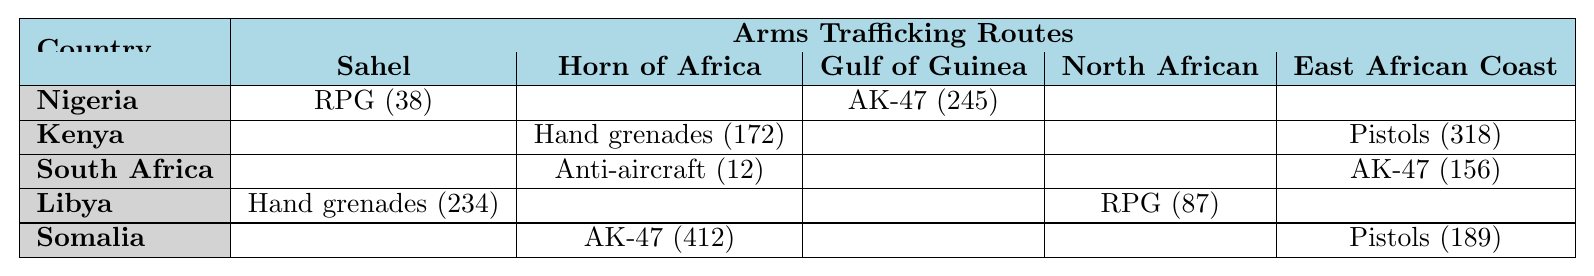What country seized the most AK-47 rifles? According to the table, Somalia seized 412 AK-47 rifles, which is the highest quantity listed for that weapon type
Answer: Somalia Which country experienced arms seizures along the Gulf of Guinea Route? From the table, Nigeria is the only country that had seizures reported along the Gulf of Guinea Route, with a total of 245 AK-47 rifles seized
Answer: Nigeria How many RPG launchers were seized in total? The total RPG launcher seizures can be calculated by adding Nigeria's 38, Libya's 87, and Kenya's 172. However, only Libya (87) and Nigeria (38) reported RPG launchers, totaling 125
Answer: 125 Did Kenya seize more pistols or hand grenades? Kenya seized 318 pistols on the East African Coast Route and 172 hand grenades on the Horn of Africa Route. Since 318 is greater than 172, it indicates that Kenya seized more pistols
Answer: Yes, more pistols What is the total quantity of weapons seized by Libya? By examining the table, Libya's seizures consist of 87 RPG launchers and 234 hand grenades. Adding them gives 87 + 234 = 321 weapons
Answer: 321 Which route has the highest number of seizures, and how many total seizures occurred on that route? The Horn of Africa Route has seizures reported as follows: 172 hand grenades in Kenya and 412 AK-47 rifles in Somalia, totaling 584 (172 + 412)
Answer: Horn of Africa Route, 584 Which country seized the least amount of Anti-aircraft guns? South Africa seized 12 Anti-aircraft guns along the Horn of Africa Route, and since there are no other countries listed with seizures of this weapon type, South Africa has the least
Answer: South Africa What percentage of the total seizures recorded are AK-47 rifles? The total number of AK-47 rifles seized is 245 (Nigeria) + 156 (South Africa) + 412 (Somalia) = 813. The total seizures across all countries are 245 + 38 + 172 + 318 + 156 + 12 + 87 + 234 + 412 + 189 = 1353. The percentage is (813/1353) * 100, which is approximately 60.1%
Answer: 60.1% Does Libya have more seizures of hand grenades or RPG launchers? Libya seized 234 hand grenades and 87 RPG launchers. Since 234 is greater than 87, it indicates Libya has more seizures of hand grenades
Answer: Yes, more hand grenades What is the average number of weapons seized per country? The total number of seizures across all countries is 1353. Since there are 5 countries, the average is 1353 / 5 = 270.6
Answer: 270.6 